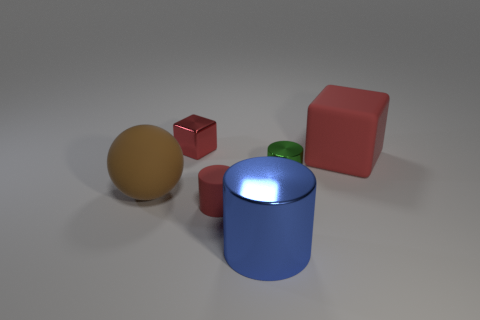What number of other objects are there of the same shape as the big blue metal object?
Provide a short and direct response. 2. Are there more tiny cubes on the left side of the large red object than large blue objects behind the tiny rubber thing?
Offer a very short reply. Yes. Is the size of the green object behind the brown ball the same as the red matte thing that is behind the brown rubber ball?
Offer a very short reply. No. The red metallic thing is what shape?
Keep it short and to the point. Cube. There is a metallic thing that is the same color as the matte cylinder; what size is it?
Give a very brief answer. Small. What color is the cylinder that is made of the same material as the big block?
Offer a terse response. Red. Are the small red cylinder and the cylinder that is behind the big brown ball made of the same material?
Your response must be concise. No. The sphere has what color?
Keep it short and to the point. Brown. There is another cylinder that is the same material as the big cylinder; what is its size?
Your response must be concise. Small. How many tiny shiny things are behind the red matte object that is on the right side of the tiny metal object in front of the big red block?
Your answer should be very brief. 1. 